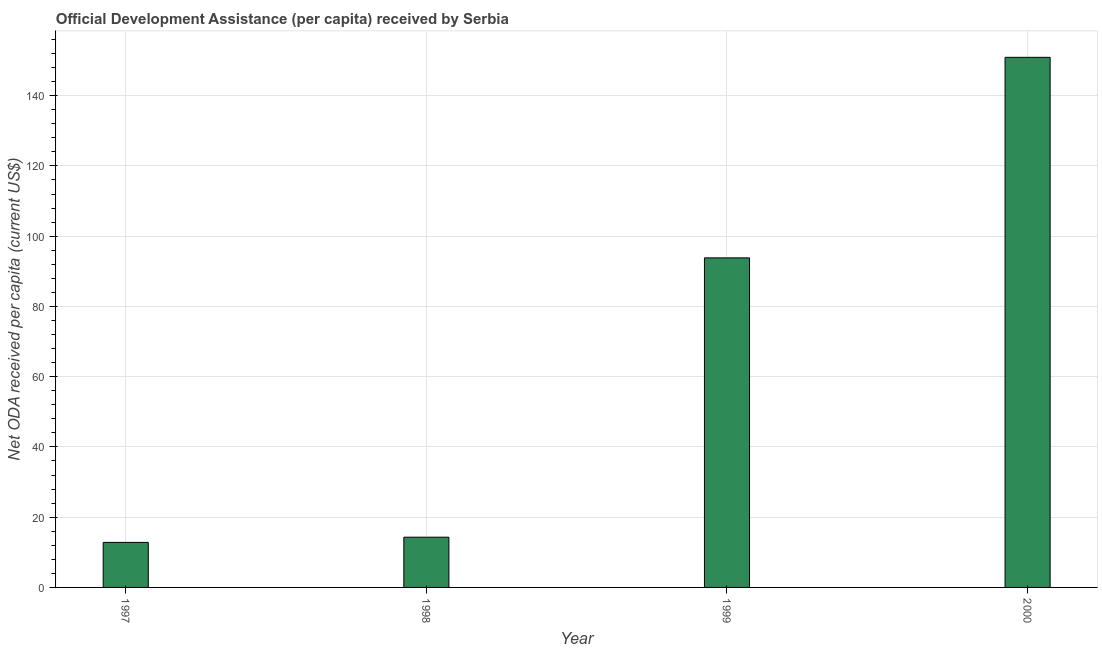Does the graph contain grids?
Ensure brevity in your answer.  Yes. What is the title of the graph?
Your answer should be very brief. Official Development Assistance (per capita) received by Serbia. What is the label or title of the X-axis?
Keep it short and to the point. Year. What is the label or title of the Y-axis?
Keep it short and to the point. Net ODA received per capita (current US$). What is the net oda received per capita in 1999?
Ensure brevity in your answer.  93.81. Across all years, what is the maximum net oda received per capita?
Your response must be concise. 150.91. Across all years, what is the minimum net oda received per capita?
Ensure brevity in your answer.  12.82. In which year was the net oda received per capita minimum?
Offer a terse response. 1997. What is the sum of the net oda received per capita?
Your answer should be very brief. 271.84. What is the difference between the net oda received per capita in 1999 and 2000?
Provide a succinct answer. -57.09. What is the average net oda received per capita per year?
Your response must be concise. 67.96. What is the median net oda received per capita?
Your answer should be very brief. 54.06. In how many years, is the net oda received per capita greater than 148 US$?
Give a very brief answer. 1. What is the ratio of the net oda received per capita in 1998 to that in 1999?
Make the answer very short. 0.15. Is the net oda received per capita in 1997 less than that in 1999?
Offer a very short reply. Yes. What is the difference between the highest and the second highest net oda received per capita?
Your answer should be compact. 57.09. Is the sum of the net oda received per capita in 1998 and 1999 greater than the maximum net oda received per capita across all years?
Ensure brevity in your answer.  No. What is the difference between the highest and the lowest net oda received per capita?
Offer a terse response. 138.09. In how many years, is the net oda received per capita greater than the average net oda received per capita taken over all years?
Your response must be concise. 2. How many bars are there?
Offer a terse response. 4. Are the values on the major ticks of Y-axis written in scientific E-notation?
Provide a short and direct response. No. What is the Net ODA received per capita (current US$) of 1997?
Make the answer very short. 12.82. What is the Net ODA received per capita (current US$) in 1998?
Ensure brevity in your answer.  14.3. What is the Net ODA received per capita (current US$) in 1999?
Offer a very short reply. 93.81. What is the Net ODA received per capita (current US$) in 2000?
Offer a terse response. 150.91. What is the difference between the Net ODA received per capita (current US$) in 1997 and 1998?
Offer a very short reply. -1.49. What is the difference between the Net ODA received per capita (current US$) in 1997 and 1999?
Offer a terse response. -81. What is the difference between the Net ODA received per capita (current US$) in 1997 and 2000?
Your answer should be very brief. -138.09. What is the difference between the Net ODA received per capita (current US$) in 1998 and 1999?
Offer a very short reply. -79.51. What is the difference between the Net ODA received per capita (current US$) in 1998 and 2000?
Provide a succinct answer. -136.61. What is the difference between the Net ODA received per capita (current US$) in 1999 and 2000?
Ensure brevity in your answer.  -57.09. What is the ratio of the Net ODA received per capita (current US$) in 1997 to that in 1998?
Offer a terse response. 0.9. What is the ratio of the Net ODA received per capita (current US$) in 1997 to that in 1999?
Your answer should be compact. 0.14. What is the ratio of the Net ODA received per capita (current US$) in 1997 to that in 2000?
Offer a terse response. 0.09. What is the ratio of the Net ODA received per capita (current US$) in 1998 to that in 1999?
Your answer should be compact. 0.15. What is the ratio of the Net ODA received per capita (current US$) in 1998 to that in 2000?
Offer a terse response. 0.1. What is the ratio of the Net ODA received per capita (current US$) in 1999 to that in 2000?
Provide a short and direct response. 0.62. 